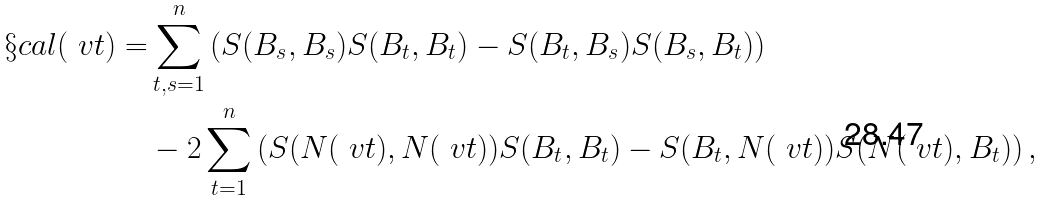<formula> <loc_0><loc_0><loc_500><loc_500>\S c a l ( \ v t ) = & \sum _ { t , s = 1 } ^ { n } \left ( S ( B _ { s } , B _ { s } ) S ( B _ { t } , B _ { t } ) - S ( B _ { t } , B _ { s } ) S ( B _ { s } , B _ { t } ) \right ) \\ & - 2 \sum _ { t = 1 } ^ { n } \left ( S ( N ( \ v t ) , N ( \ v t ) ) S ( B _ { t } , B _ { t } ) - S ( B _ { t } , N ( \ v t ) ) S ( N ( \ v t ) , B _ { t } ) \right ) ,</formula> 